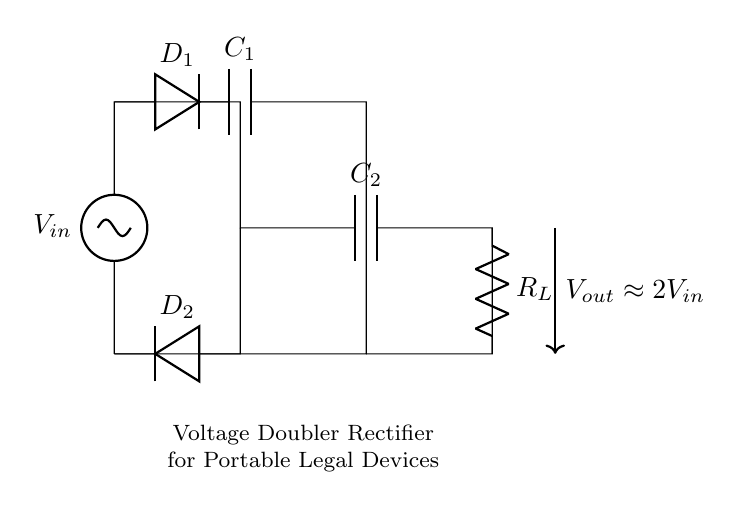What is the input voltage denoted in the circuit? The input voltage is depicted by the label V_in at the left side of the circuit diagram.
Answer: V_in What are the components used in this voltage doubler circuit? The components shown in the circuit include two capacitors (C_1 and C_2), two diodes (D_1 and D_2), and a resistor (R_L).
Answer: C_1, C_2, D_1, D_2, R_L How does the output voltage relate to the input voltage? The output voltage is approximately double the input voltage, as indicated by the label stating V_out is about 2V_in.
Answer: 2V_in Which component serves to store charge in this circuit? The capacitors, specifically C_1 and C_2, are the components that store electrical charge in the circuit.
Answer: C_1, C_2 What is the role of the diodes in this rectifier circuit? The diodes (D_1 and D_2) allow current to flow in one direction only, enabling the circuit to convert alternating current to direct current effectively.
Answer: To rectify the current Which resistive load is present in this voltage doubler rectifier? The resistive load in this circuit is represented as R_L, which draws power from the output of the voltage doubler.
Answer: R_L 